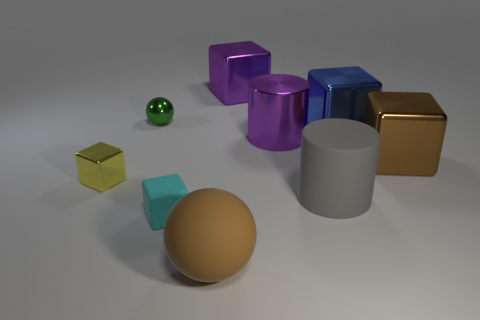How many red things are either matte blocks or rubber cylinders?
Offer a very short reply. 0. What number of other things are the same size as the cyan rubber thing?
Your answer should be very brief. 2. How many small things are either rubber balls or green rubber things?
Offer a very short reply. 0. Is the size of the blue object the same as the object that is in front of the cyan rubber object?
Provide a succinct answer. Yes. How many other things are the same shape as the small matte thing?
Your response must be concise. 4. There is a brown object that is the same material as the large gray object; what is its shape?
Offer a very short reply. Sphere. Are any big brown metal blocks visible?
Your answer should be compact. Yes. Is the number of matte things that are behind the cyan matte cube less than the number of purple cylinders that are on the right side of the brown metal cube?
Make the answer very short. No. There is a rubber thing that is to the left of the large ball; what shape is it?
Offer a terse response. Cube. Do the big blue block and the big gray cylinder have the same material?
Keep it short and to the point. No. 